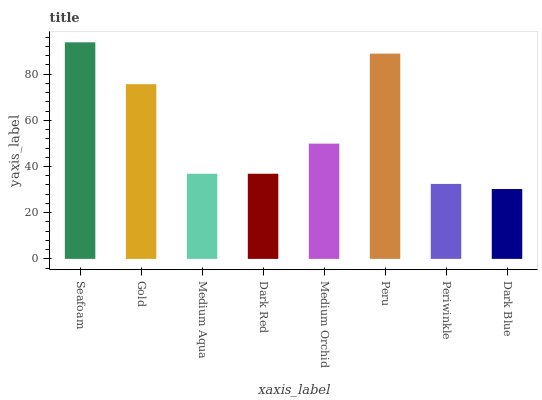Is Gold the minimum?
Answer yes or no. No. Is Gold the maximum?
Answer yes or no. No. Is Seafoam greater than Gold?
Answer yes or no. Yes. Is Gold less than Seafoam?
Answer yes or no. Yes. Is Gold greater than Seafoam?
Answer yes or no. No. Is Seafoam less than Gold?
Answer yes or no. No. Is Medium Orchid the high median?
Answer yes or no. Yes. Is Dark Red the low median?
Answer yes or no. Yes. Is Dark Blue the high median?
Answer yes or no. No. Is Peru the low median?
Answer yes or no. No. 